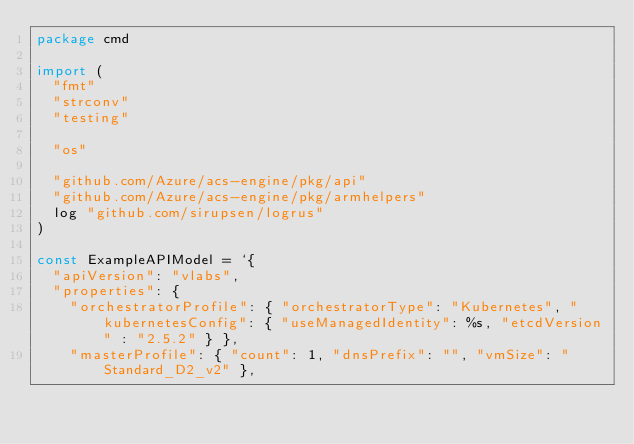Convert code to text. <code><loc_0><loc_0><loc_500><loc_500><_Go_>package cmd

import (
	"fmt"
	"strconv"
	"testing"

	"os"

	"github.com/Azure/acs-engine/pkg/api"
	"github.com/Azure/acs-engine/pkg/armhelpers"
	log "github.com/sirupsen/logrus"
)

const ExampleAPIModel = `{
  "apiVersion": "vlabs",
  "properties": {
		"orchestratorProfile": { "orchestratorType": "Kubernetes", "kubernetesConfig": { "useManagedIdentity": %s, "etcdVersion" : "2.5.2" } },
    "masterProfile": { "count": 1, "dnsPrefix": "", "vmSize": "Standard_D2_v2" },</code> 